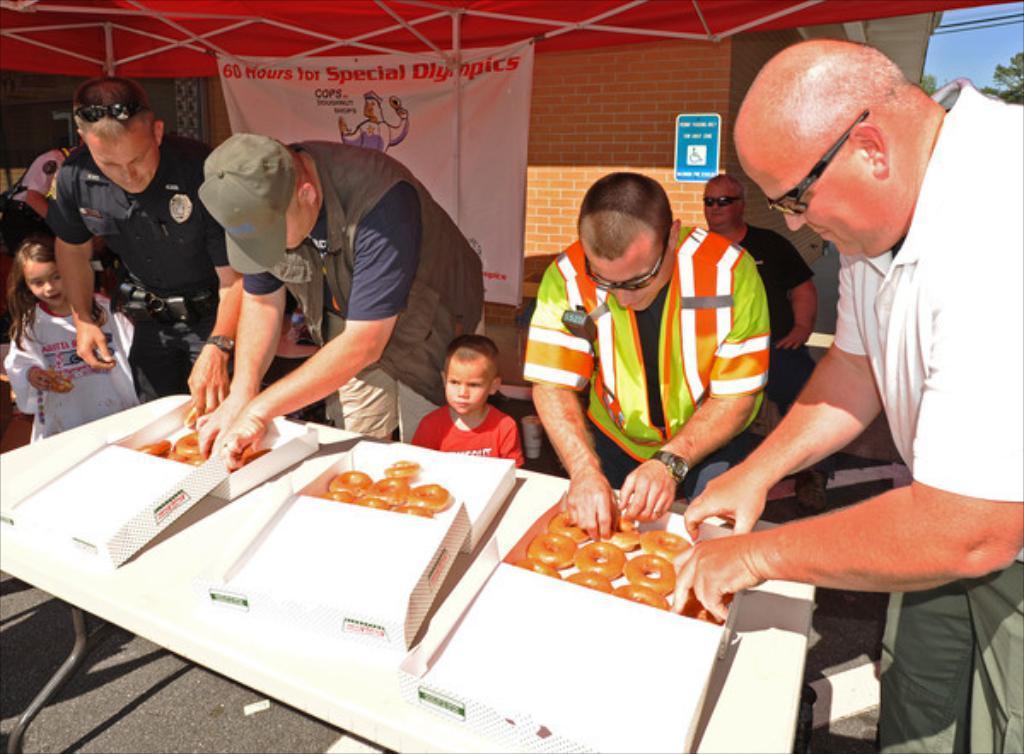Please provide a concise description of this image. In this image there are four person who are holding a sweets. On the table there is a sweet boxes, beside a table there is a kid who is wearing a red shirt. On the background we can see a brick wall and a sign board. On the top right corner we can see a sky and a tree. This man wearing a security jacket. On the left there is a girl who is looking to a sweet. 